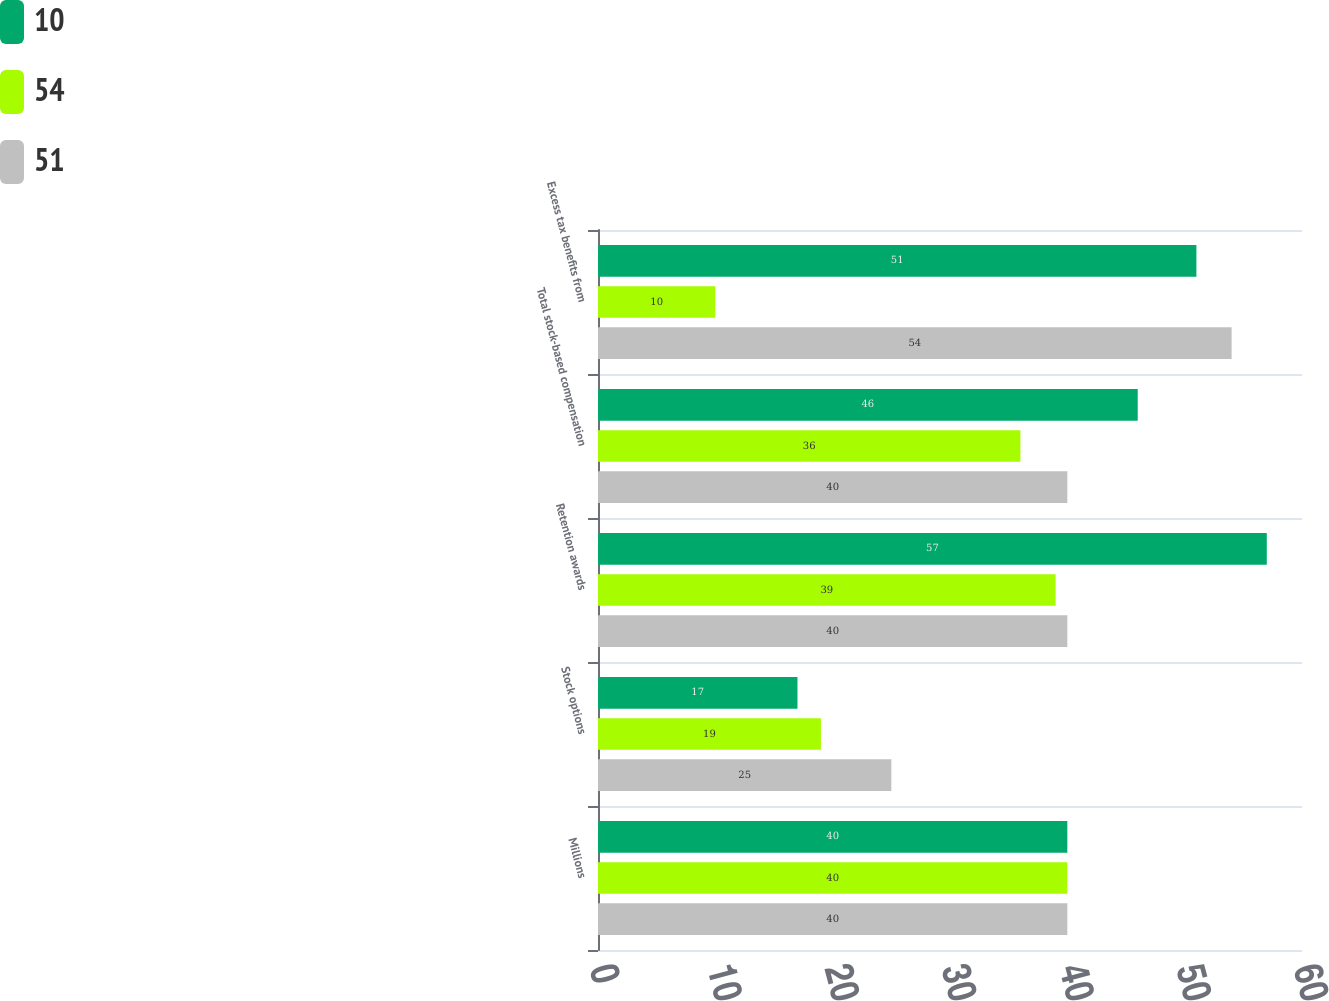Convert chart. <chart><loc_0><loc_0><loc_500><loc_500><stacked_bar_chart><ecel><fcel>Millions<fcel>Stock options<fcel>Retention awards<fcel>Total stock-based compensation<fcel>Excess tax benefits from<nl><fcel>10<fcel>40<fcel>17<fcel>57<fcel>46<fcel>51<nl><fcel>54<fcel>40<fcel>19<fcel>39<fcel>36<fcel>10<nl><fcel>51<fcel>40<fcel>25<fcel>40<fcel>40<fcel>54<nl></chart> 